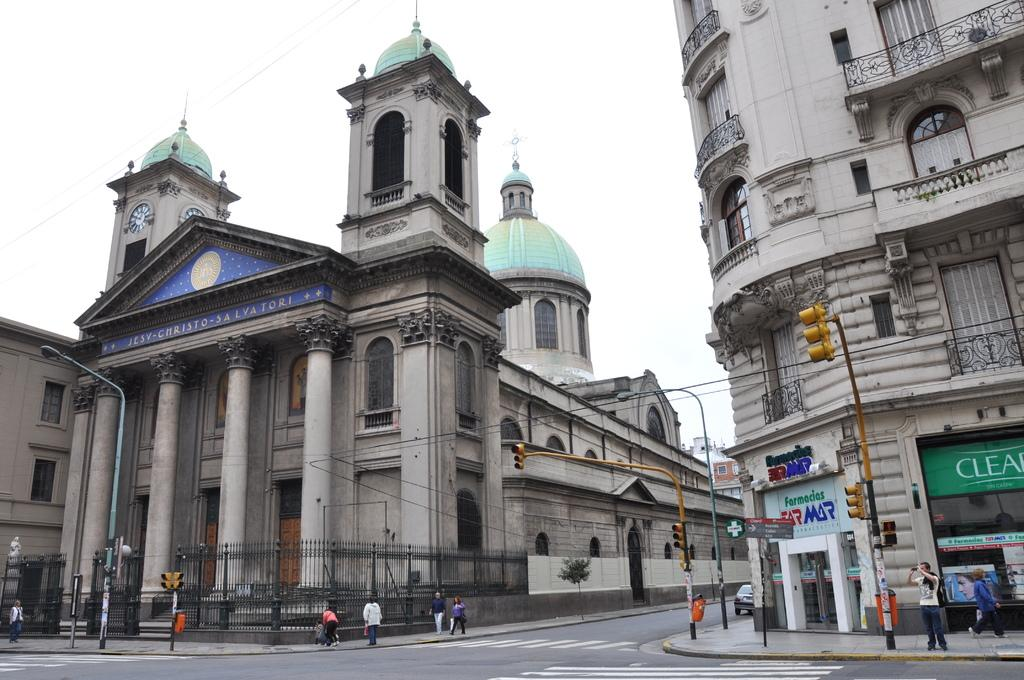What type of structure is the main subject of the image? There is a castle in the image. What can be seen near the castle? There is a fence in the image. Are there any people in the image? Yes, there are people in the image. What other structures can be seen in the image? There are traffic lights and a building in the image. What else is present in the image? There are boards in the image. What is visible in the background of the image? The sky is visible in the background of the image. How deep is the hole in the image? There is no hole present in the image. 